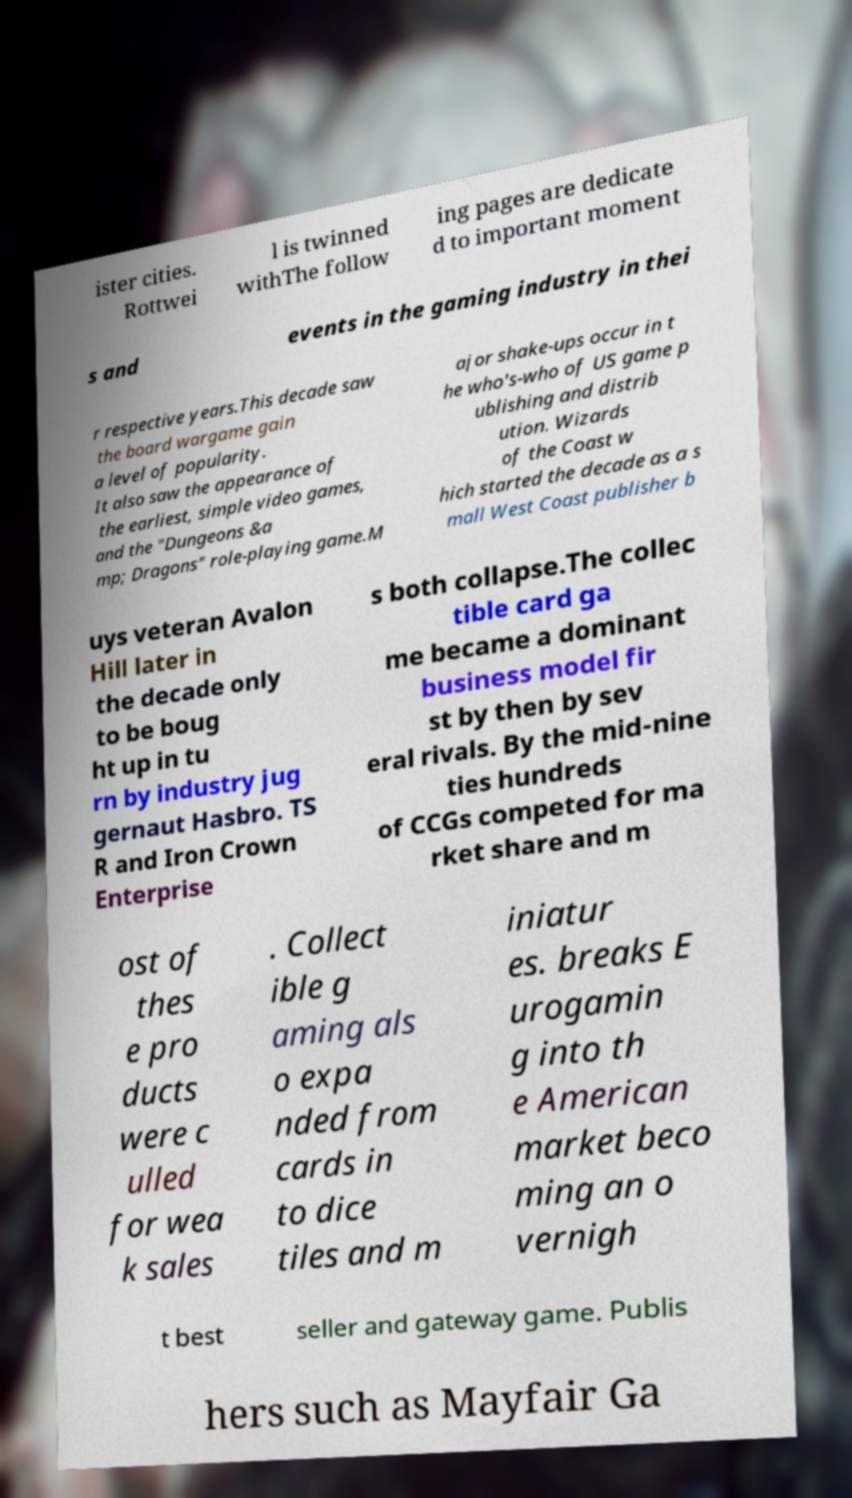Please read and relay the text visible in this image. What does it say? ister cities. Rottwei l is twinned withThe follow ing pages are dedicate d to important moment s and events in the gaming industry in thei r respective years.This decade saw the board wargame gain a level of popularity. It also saw the appearance of the earliest, simple video games, and the "Dungeons &a mp; Dragons" role-playing game.M ajor shake-ups occur in t he who's-who of US game p ublishing and distrib ution. Wizards of the Coast w hich started the decade as a s mall West Coast publisher b uys veteran Avalon Hill later in the decade only to be boug ht up in tu rn by industry jug gernaut Hasbro. TS R and Iron Crown Enterprise s both collapse.The collec tible card ga me became a dominant business model fir st by then by sev eral rivals. By the mid-nine ties hundreds of CCGs competed for ma rket share and m ost of thes e pro ducts were c ulled for wea k sales . Collect ible g aming als o expa nded from cards in to dice tiles and m iniatur es. breaks E urogamin g into th e American market beco ming an o vernigh t best seller and gateway game. Publis hers such as Mayfair Ga 